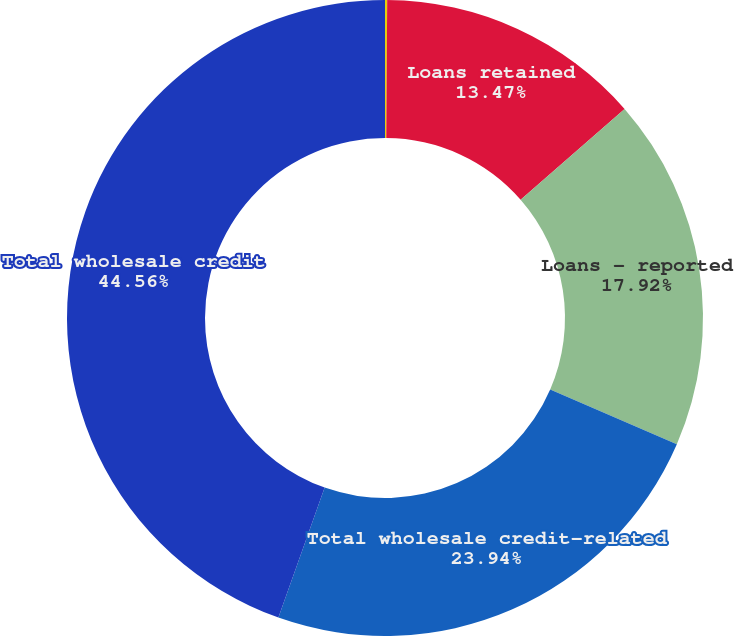Convert chart to OTSL. <chart><loc_0><loc_0><loc_500><loc_500><pie_chart><fcel>(in millions)<fcel>Loans retained<fcel>Loans - reported<fcel>Total wholesale credit-related<fcel>Total wholesale credit<nl><fcel>0.11%<fcel>13.47%<fcel>17.92%<fcel>23.94%<fcel>44.56%<nl></chart> 